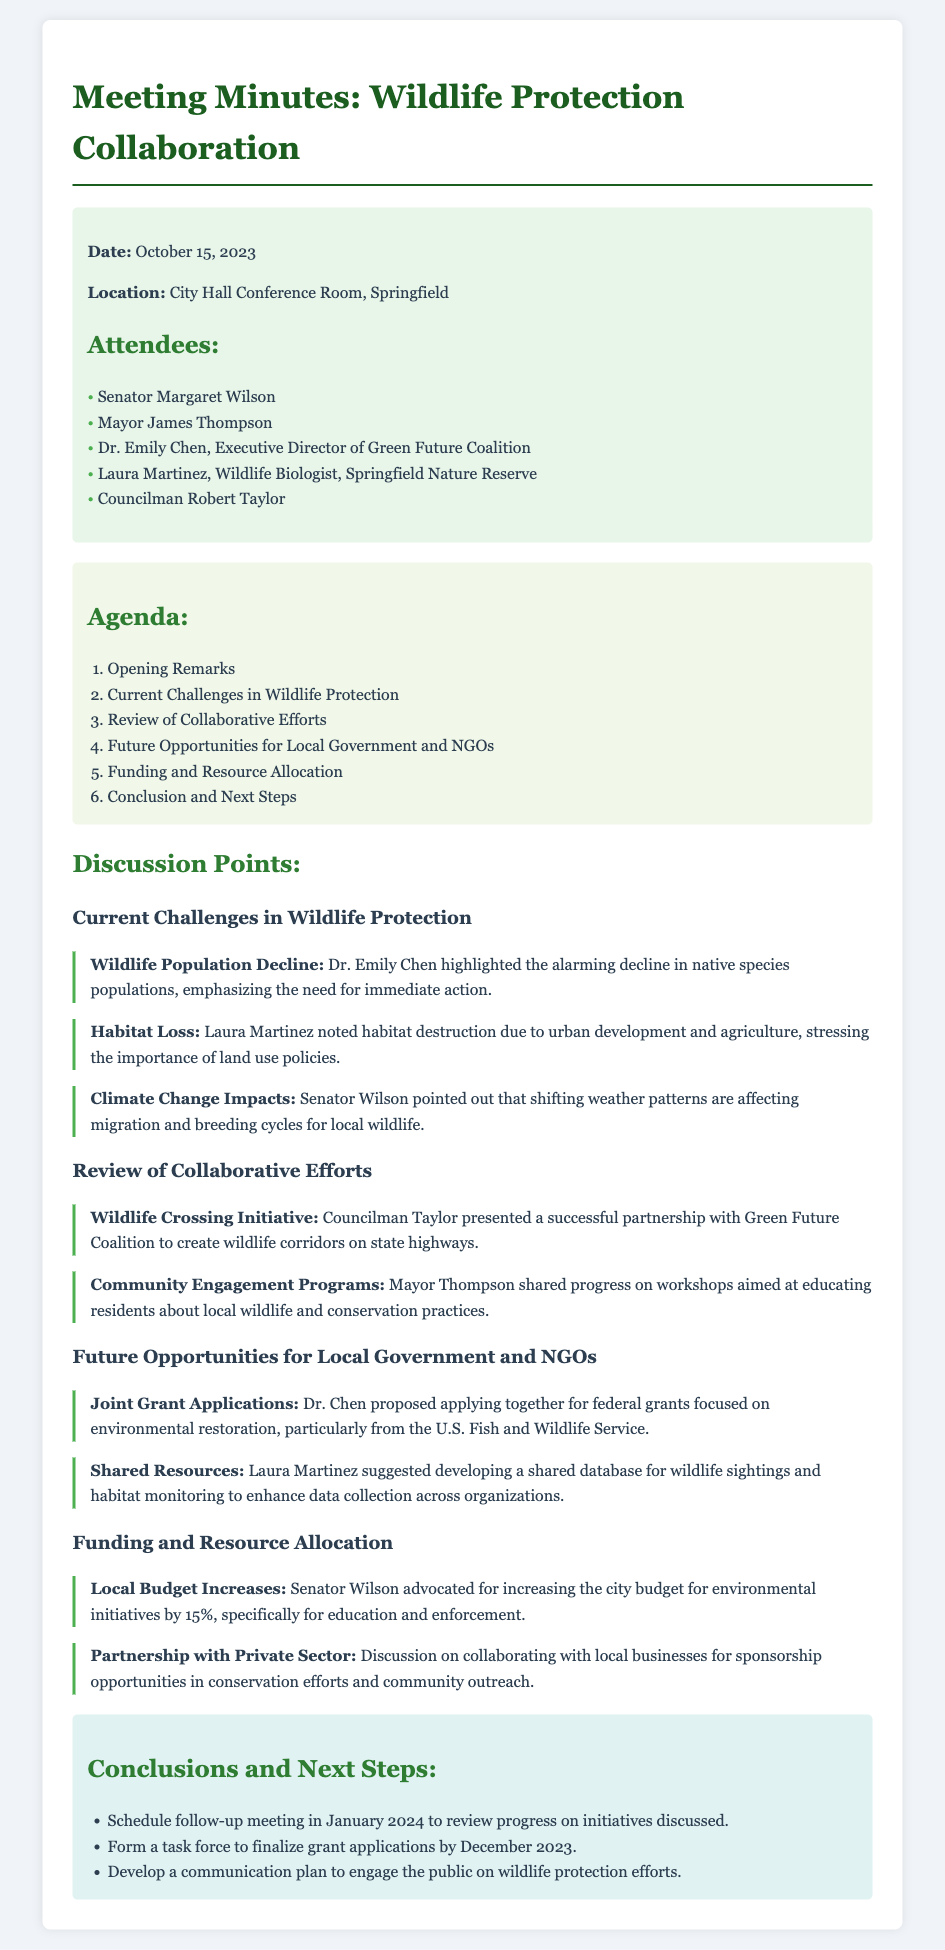what was the date of the meeting? The date of the meeting is explicitly stated at the beginning of the document.
Answer: October 15, 2023 who highlighted the decline in native species populations? The document mentions Dr. Emily Chen specifically addressing the decline in wildlife populations.
Answer: Dr. Emily Chen what initiative was presented by Councilman Taylor? The document mentions a specific initiative regarding wildlife corridors presented by Councilman Taylor.
Answer: Wildlife Crossing Initiative how much does Senator Wilson advocate to increase the city budget for environmental initiatives? Senator Wilson's advocacy for the budget increase is detailed in the funding section.
Answer: 15% what is proposed to be developed for wildlife sightings and habitat monitoring? Laura Martinez suggested a specific development related to wildlife data collection in her discussion point.
Answer: Shared database what is the follow-up meeting scheduled for? The document lists the purpose of the follow-up meeting in the conclusions section.
Answer: Review progress on initiatives discussed who shared progress on community engagement programs? The document specifically mentions who shared updates on community engagement.
Answer: Mayor Thompson what is scheduled to happen by December 2023? The conclusions section outlines the timeline for a specific action to be completed by December 2023.
Answer: Finalize grant applications 